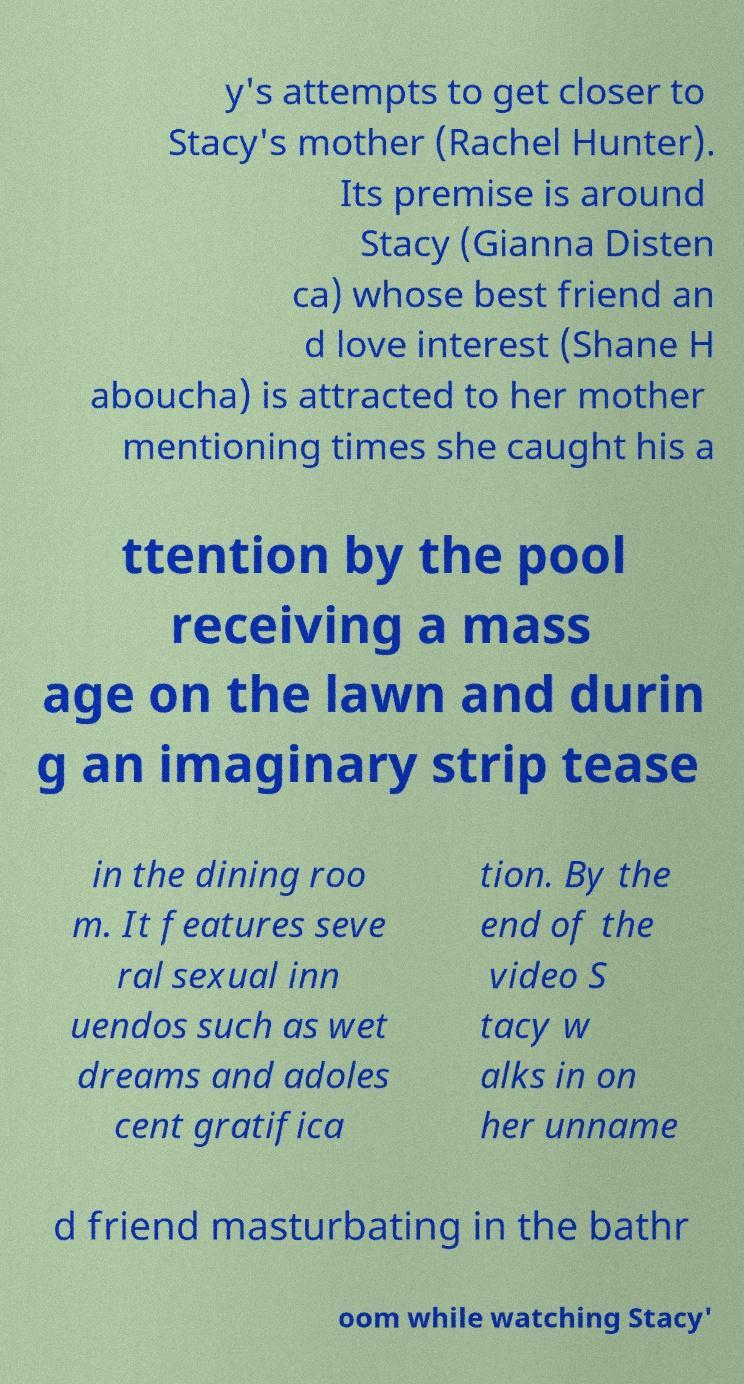What messages or text are displayed in this image? I need them in a readable, typed format. y's attempts to get closer to Stacy's mother (Rachel Hunter). Its premise is around Stacy (Gianna Disten ca) whose best friend an d love interest (Shane H aboucha) is attracted to her mother mentioning times she caught his a ttention by the pool receiving a mass age on the lawn and durin g an imaginary strip tease in the dining roo m. It features seve ral sexual inn uendos such as wet dreams and adoles cent gratifica tion. By the end of the video S tacy w alks in on her unname d friend masturbating in the bathr oom while watching Stacy' 